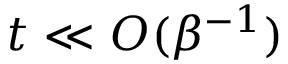<formula> <loc_0><loc_0><loc_500><loc_500>t \ll O ( \beta ^ { - 1 } )</formula> 